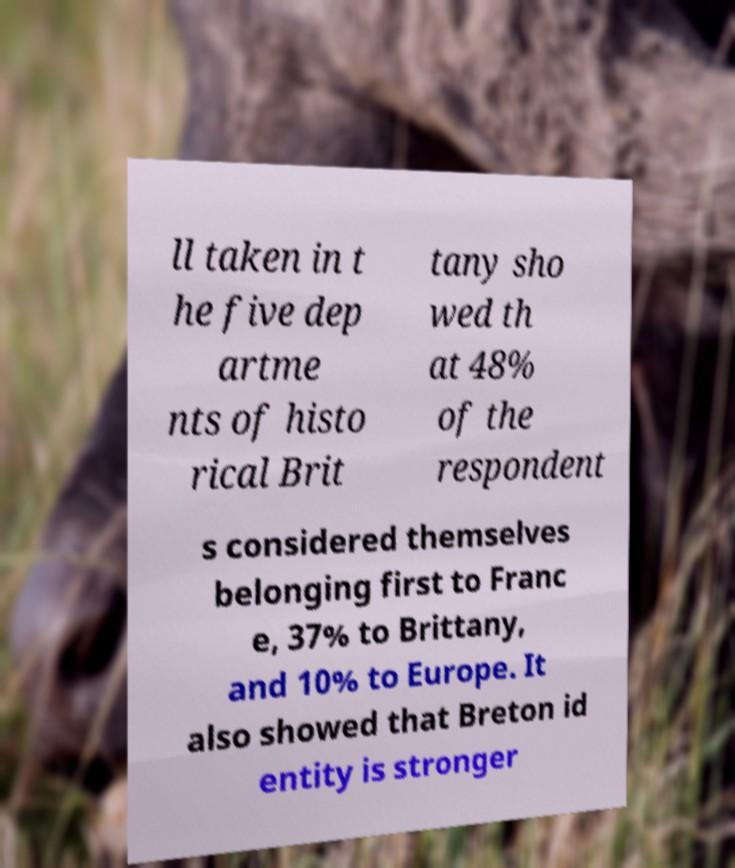Can you accurately transcribe the text from the provided image for me? ll taken in t he five dep artme nts of histo rical Brit tany sho wed th at 48% of the respondent s considered themselves belonging first to Franc e, 37% to Brittany, and 10% to Europe. It also showed that Breton id entity is stronger 